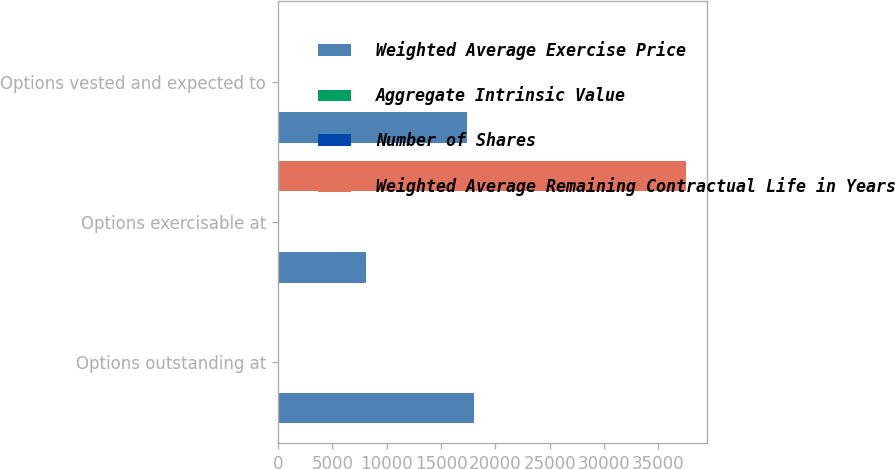Convert chart to OTSL. <chart><loc_0><loc_0><loc_500><loc_500><stacked_bar_chart><ecel><fcel>Options outstanding at<fcel>Options exercisable at<fcel>Options vested and expected to<nl><fcel>Weighted Average Exercise Price<fcel>18039<fcel>8141<fcel>17385<nl><fcel>Aggregate Intrinsic Value<fcel>17.4<fcel>18.73<fcel>17.47<nl><fcel>Number of Shares<fcel>4.4<fcel>3.15<fcel>4.33<nl><fcel>Weighted Average Remaining Contractual Life in Years<fcel>18.1<fcel>37574<fcel>18.1<nl></chart> 